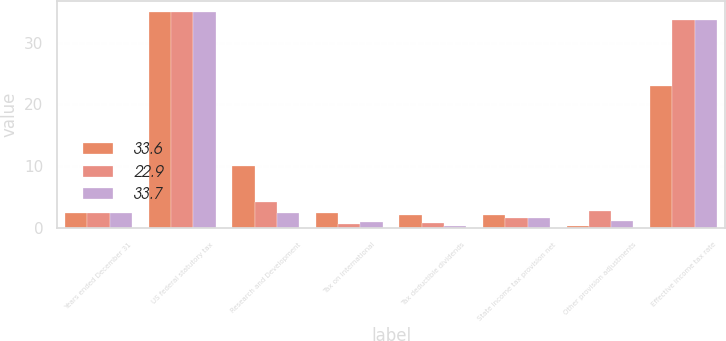Convert chart. <chart><loc_0><loc_0><loc_500><loc_500><stacked_bar_chart><ecel><fcel>Years ended December 31<fcel>US federal statutory tax<fcel>Research and Development<fcel>Tax on international<fcel>Tax deductible dividends<fcel>State income tax provision net<fcel>Other provision adjustments<fcel>Effective income tax rate<nl><fcel>33.6<fcel>2.4<fcel>35<fcel>10.1<fcel>2.4<fcel>2.2<fcel>2.2<fcel>0.4<fcel>22.9<nl><fcel>22.9<fcel>2.4<fcel>35<fcel>4.3<fcel>0.7<fcel>0.8<fcel>1.7<fcel>2.7<fcel>33.6<nl><fcel>33.7<fcel>2.4<fcel>35<fcel>2.4<fcel>1<fcel>0.4<fcel>1.6<fcel>1.1<fcel>33.7<nl></chart> 